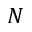<formula> <loc_0><loc_0><loc_500><loc_500>N</formula> 